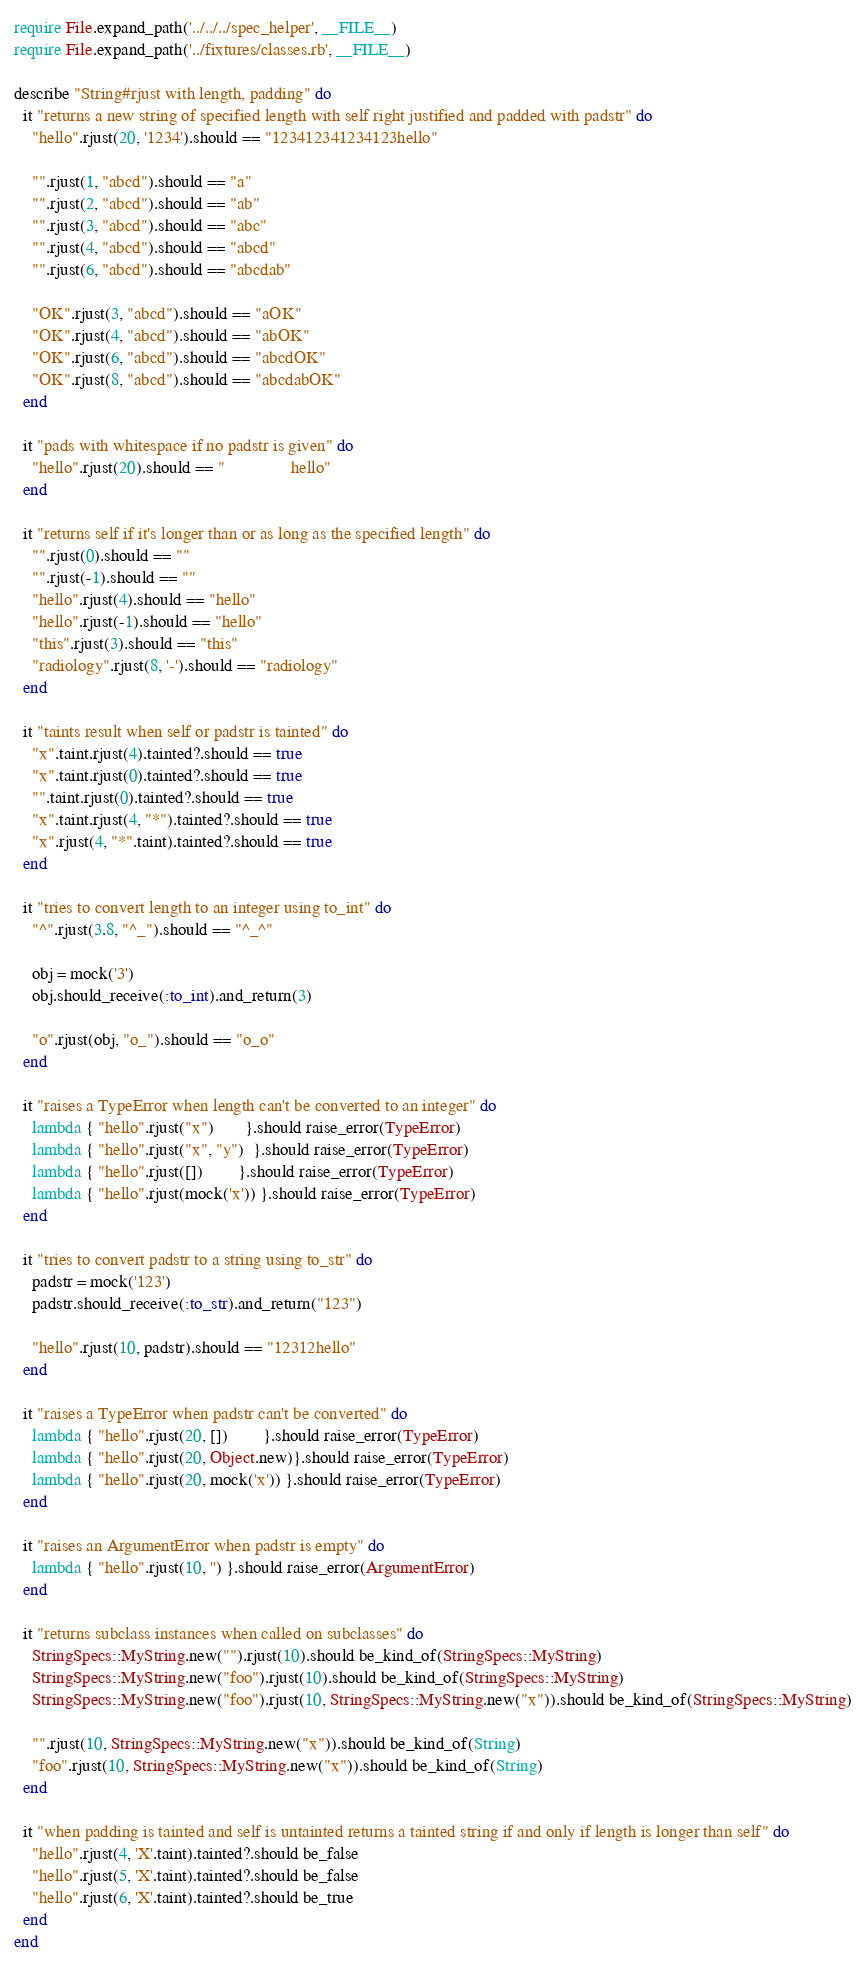<code> <loc_0><loc_0><loc_500><loc_500><_Ruby_>require File.expand_path('../../../spec_helper', __FILE__)
require File.expand_path('../fixtures/classes.rb', __FILE__)

describe "String#rjust with length, padding" do
  it "returns a new string of specified length with self right justified and padded with padstr" do
    "hello".rjust(20, '1234').should == "123412341234123hello"

    "".rjust(1, "abcd").should == "a"
    "".rjust(2, "abcd").should == "ab"
    "".rjust(3, "abcd").should == "abc"
    "".rjust(4, "abcd").should == "abcd"
    "".rjust(6, "abcd").should == "abcdab"

    "OK".rjust(3, "abcd").should == "aOK"
    "OK".rjust(4, "abcd").should == "abOK"
    "OK".rjust(6, "abcd").should == "abcdOK"
    "OK".rjust(8, "abcd").should == "abcdabOK"
  end

  it "pads with whitespace if no padstr is given" do
    "hello".rjust(20).should == "               hello"
  end

  it "returns self if it's longer than or as long as the specified length" do
    "".rjust(0).should == ""
    "".rjust(-1).should == ""
    "hello".rjust(4).should == "hello"
    "hello".rjust(-1).should == "hello"
    "this".rjust(3).should == "this"
    "radiology".rjust(8, '-').should == "radiology"
  end

  it "taints result when self or padstr is tainted" do
    "x".taint.rjust(4).tainted?.should == true
    "x".taint.rjust(0).tainted?.should == true
    "".taint.rjust(0).tainted?.should == true
    "x".taint.rjust(4, "*").tainted?.should == true
    "x".rjust(4, "*".taint).tainted?.should == true
  end

  it "tries to convert length to an integer using to_int" do
    "^".rjust(3.8, "^_").should == "^_^"

    obj = mock('3')
    obj.should_receive(:to_int).and_return(3)

    "o".rjust(obj, "o_").should == "o_o"
  end

  it "raises a TypeError when length can't be converted to an integer" do
    lambda { "hello".rjust("x")       }.should raise_error(TypeError)
    lambda { "hello".rjust("x", "y")  }.should raise_error(TypeError)
    lambda { "hello".rjust([])        }.should raise_error(TypeError)
    lambda { "hello".rjust(mock('x')) }.should raise_error(TypeError)
  end

  it "tries to convert padstr to a string using to_str" do
    padstr = mock('123')
    padstr.should_receive(:to_str).and_return("123")

    "hello".rjust(10, padstr).should == "12312hello"
  end

  it "raises a TypeError when padstr can't be converted" do
    lambda { "hello".rjust(20, [])        }.should raise_error(TypeError)
    lambda { "hello".rjust(20, Object.new)}.should raise_error(TypeError)
    lambda { "hello".rjust(20, mock('x')) }.should raise_error(TypeError)
  end

  it "raises an ArgumentError when padstr is empty" do
    lambda { "hello".rjust(10, '') }.should raise_error(ArgumentError)
  end

  it "returns subclass instances when called on subclasses" do
    StringSpecs::MyString.new("").rjust(10).should be_kind_of(StringSpecs::MyString)
    StringSpecs::MyString.new("foo").rjust(10).should be_kind_of(StringSpecs::MyString)
    StringSpecs::MyString.new("foo").rjust(10, StringSpecs::MyString.new("x")).should be_kind_of(StringSpecs::MyString)

    "".rjust(10, StringSpecs::MyString.new("x")).should be_kind_of(String)
    "foo".rjust(10, StringSpecs::MyString.new("x")).should be_kind_of(String)
  end

  it "when padding is tainted and self is untainted returns a tainted string if and only if length is longer than self" do
    "hello".rjust(4, 'X'.taint).tainted?.should be_false
    "hello".rjust(5, 'X'.taint).tainted?.should be_false
    "hello".rjust(6, 'X'.taint).tainted?.should be_true
  end
end
</code> 